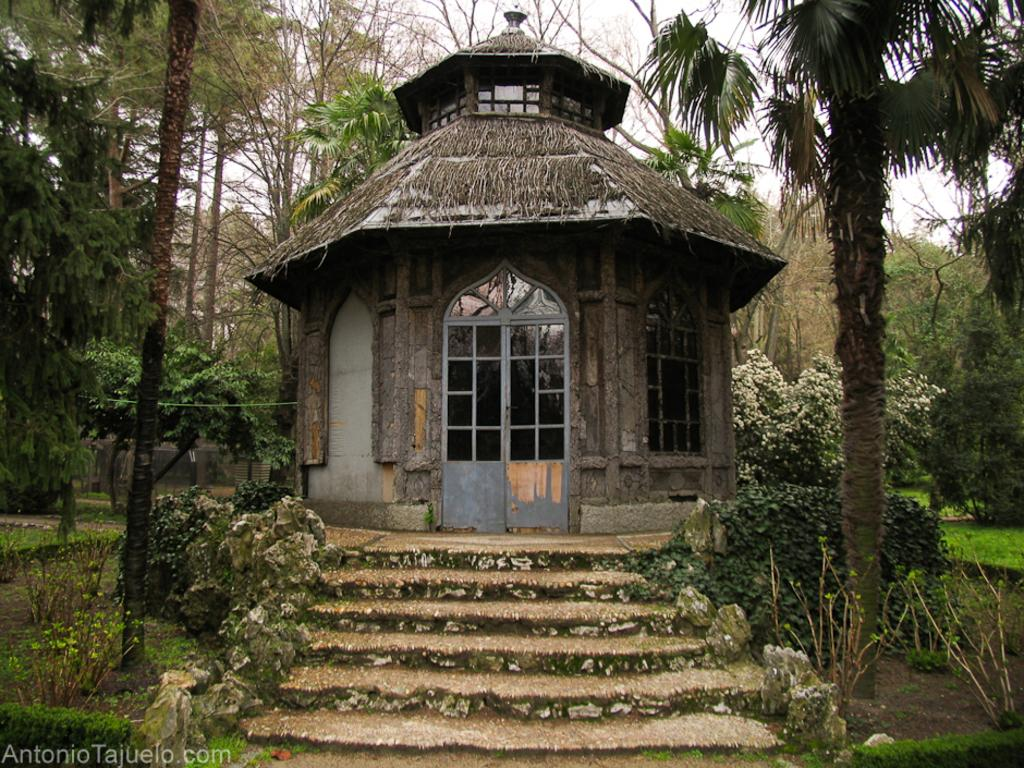What type of structure is visible in the image? There is a house in the image. What architectural feature can be seen in the image? There are stairs in the image. What type of vegetation is present in the image? There is grass, plants, and trees in the image. What part of the natural environment is visible in the image? The sky is visible at the top of the image. How many men are participating in the birth depicted in the image? There is no depiction of a voyage, men, or birth in the image; it features a house, stairs, grass, plants, trees, and the sky. 